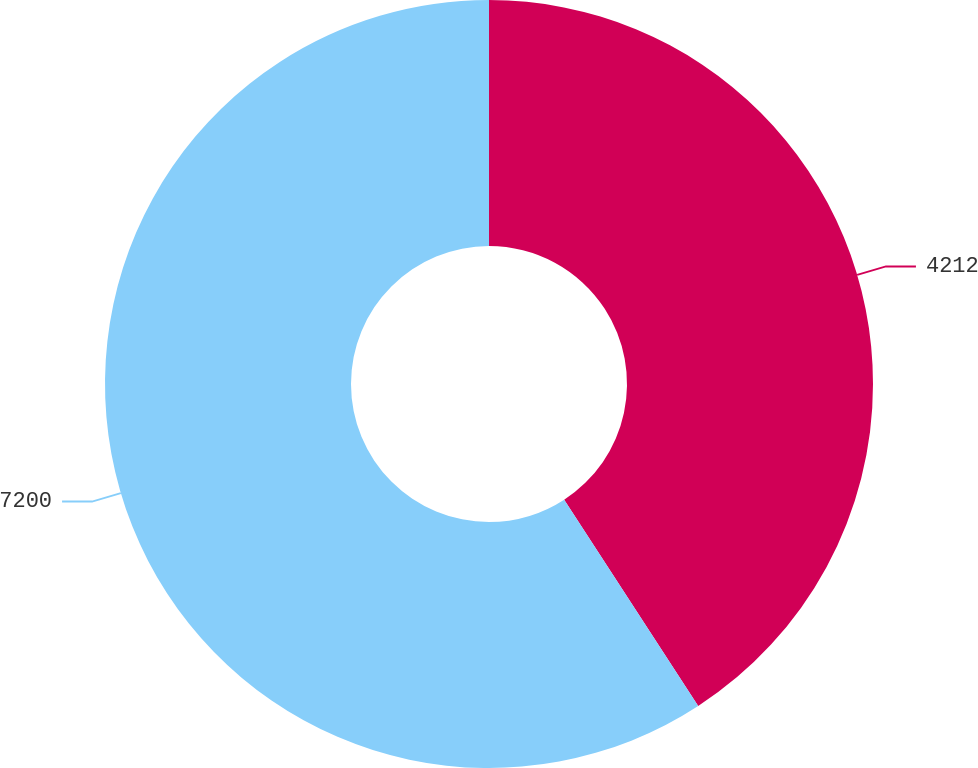Convert chart to OTSL. <chart><loc_0><loc_0><loc_500><loc_500><pie_chart><fcel>4212<fcel>7200<nl><fcel>40.83%<fcel>59.17%<nl></chart> 